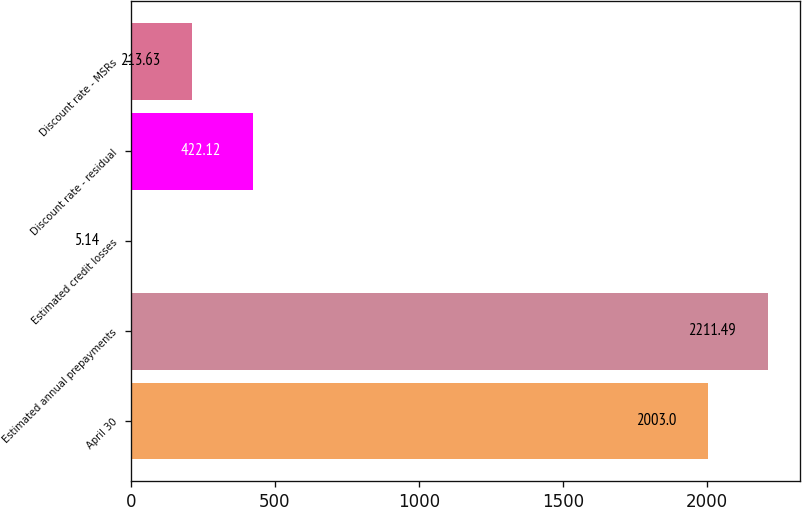Convert chart. <chart><loc_0><loc_0><loc_500><loc_500><bar_chart><fcel>April 30<fcel>Estimated annual prepayments<fcel>Estimated credit losses<fcel>Discount rate - residual<fcel>Discount rate - MSRs<nl><fcel>2003<fcel>2211.49<fcel>5.14<fcel>422.12<fcel>213.63<nl></chart> 